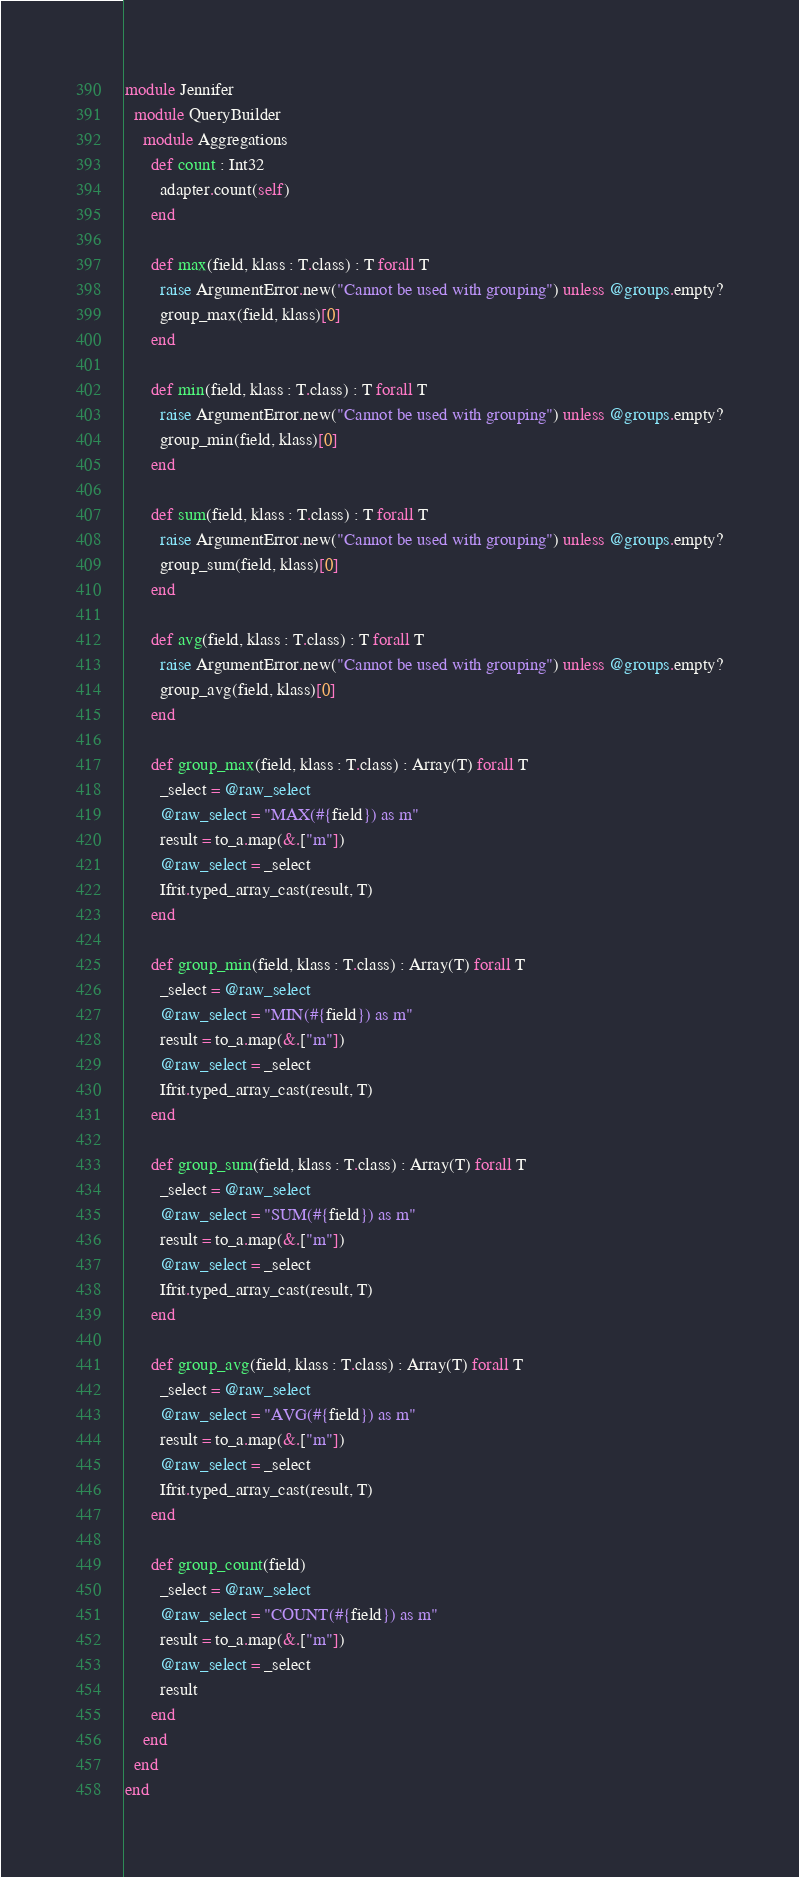Convert code to text. <code><loc_0><loc_0><loc_500><loc_500><_Crystal_>module Jennifer
  module QueryBuilder
    module Aggregations
      def count : Int32
        adapter.count(self)
      end

      def max(field, klass : T.class) : T forall T
        raise ArgumentError.new("Cannot be used with grouping") unless @groups.empty?
        group_max(field, klass)[0]
      end

      def min(field, klass : T.class) : T forall T
        raise ArgumentError.new("Cannot be used with grouping") unless @groups.empty?
        group_min(field, klass)[0]
      end

      def sum(field, klass : T.class) : T forall T
        raise ArgumentError.new("Cannot be used with grouping") unless @groups.empty?
        group_sum(field, klass)[0]
      end

      def avg(field, klass : T.class) : T forall T
        raise ArgumentError.new("Cannot be used with grouping") unless @groups.empty?
        group_avg(field, klass)[0]
      end

      def group_max(field, klass : T.class) : Array(T) forall T
        _select = @raw_select
        @raw_select = "MAX(#{field}) as m"
        result = to_a.map(&.["m"])
        @raw_select = _select
        Ifrit.typed_array_cast(result, T)
      end

      def group_min(field, klass : T.class) : Array(T) forall T
        _select = @raw_select
        @raw_select = "MIN(#{field}) as m"
        result = to_a.map(&.["m"])
        @raw_select = _select
        Ifrit.typed_array_cast(result, T)
      end

      def group_sum(field, klass : T.class) : Array(T) forall T
        _select = @raw_select
        @raw_select = "SUM(#{field}) as m"
        result = to_a.map(&.["m"])
        @raw_select = _select
        Ifrit.typed_array_cast(result, T)
      end

      def group_avg(field, klass : T.class) : Array(T) forall T
        _select = @raw_select
        @raw_select = "AVG(#{field}) as m"
        result = to_a.map(&.["m"])
        @raw_select = _select
        Ifrit.typed_array_cast(result, T)
      end

      def group_count(field)
        _select = @raw_select
        @raw_select = "COUNT(#{field}) as m"
        result = to_a.map(&.["m"])
        @raw_select = _select
        result
      end
    end
  end
end
</code> 